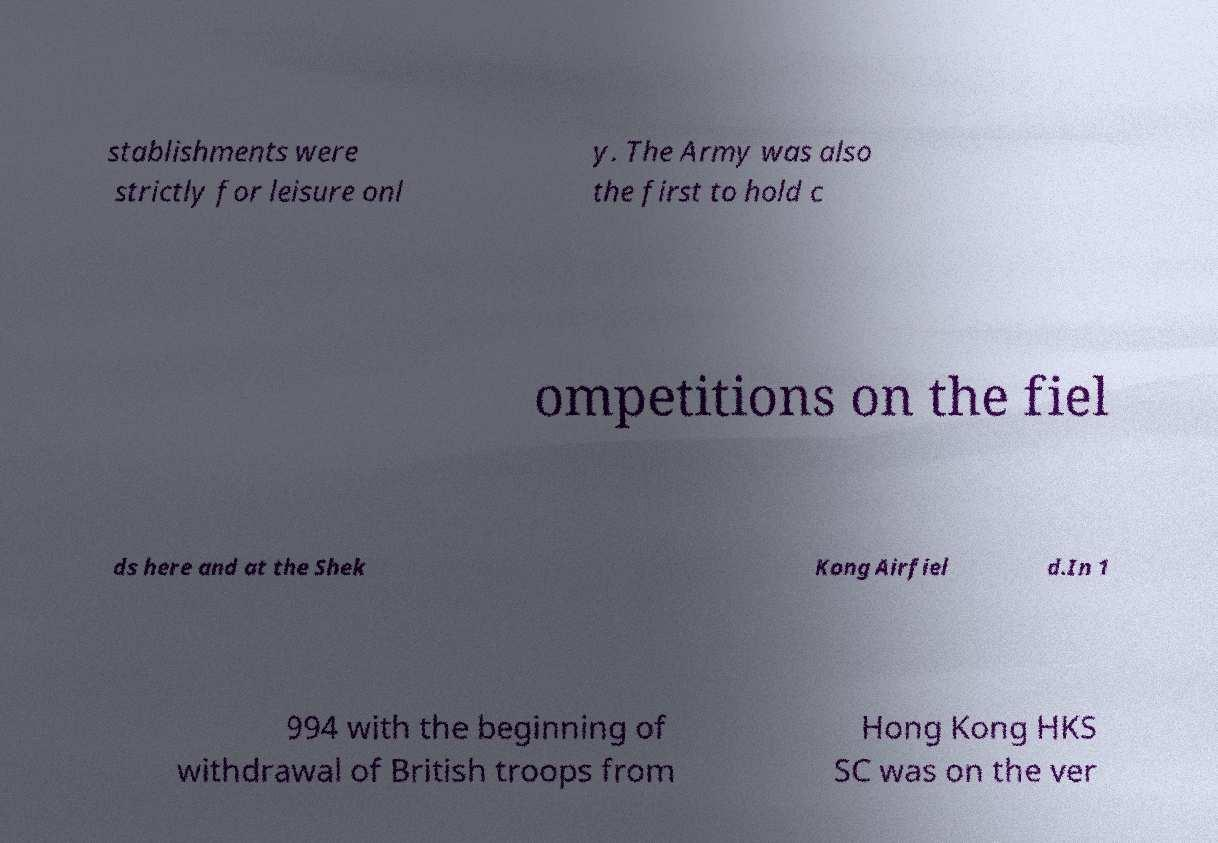Can you read and provide the text displayed in the image?This photo seems to have some interesting text. Can you extract and type it out for me? stablishments were strictly for leisure onl y. The Army was also the first to hold c ompetitions on the fiel ds here and at the Shek Kong Airfiel d.In 1 994 with the beginning of withdrawal of British troops from Hong Kong HKS SC was on the ver 